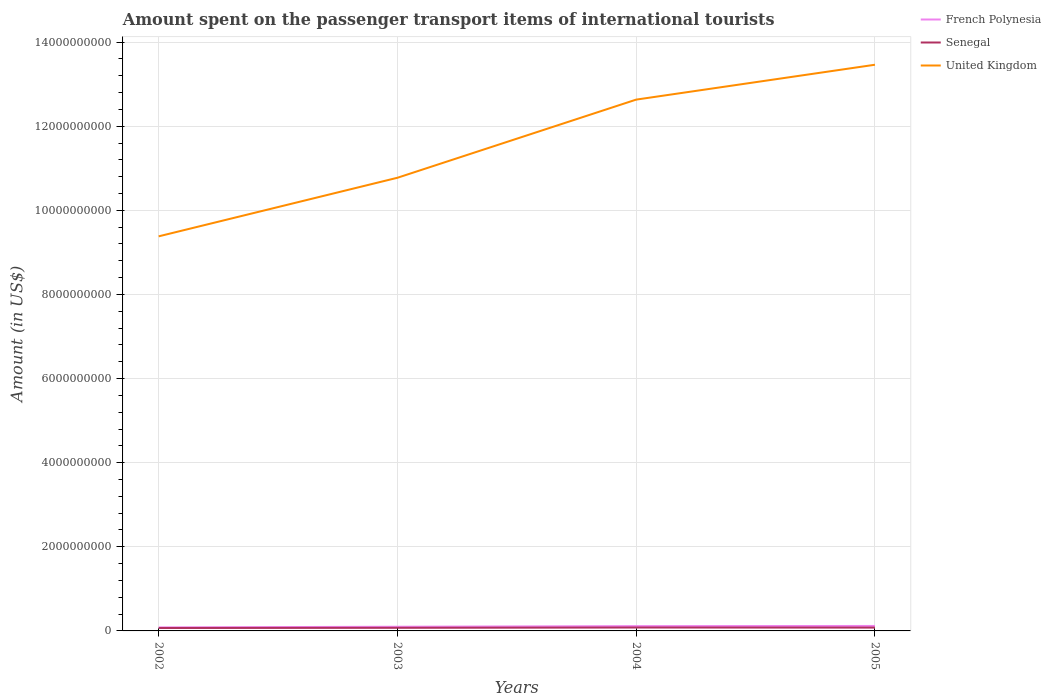Does the line corresponding to United Kingdom intersect with the line corresponding to French Polynesia?
Provide a short and direct response. No. Across all years, what is the maximum amount spent on the passenger transport items of international tourists in French Polynesia?
Offer a terse response. 8.40e+07. What is the total amount spent on the passenger transport items of international tourists in United Kingdom in the graph?
Provide a short and direct response. -2.69e+09. What is the difference between the highest and the second highest amount spent on the passenger transport items of international tourists in Senegal?
Provide a succinct answer. 1.20e+07. How many lines are there?
Ensure brevity in your answer.  3. How many years are there in the graph?
Offer a very short reply. 4. Are the values on the major ticks of Y-axis written in scientific E-notation?
Give a very brief answer. No. Does the graph contain grids?
Make the answer very short. Yes. How many legend labels are there?
Offer a very short reply. 3. How are the legend labels stacked?
Keep it short and to the point. Vertical. What is the title of the graph?
Your answer should be very brief. Amount spent on the passenger transport items of international tourists. Does "Nepal" appear as one of the legend labels in the graph?
Ensure brevity in your answer.  No. What is the Amount (in US$) of French Polynesia in 2002?
Ensure brevity in your answer.  8.40e+07. What is the Amount (in US$) in Senegal in 2002?
Your response must be concise. 6.90e+07. What is the Amount (in US$) in United Kingdom in 2002?
Keep it short and to the point. 9.38e+09. What is the Amount (in US$) of French Polynesia in 2003?
Make the answer very short. 9.90e+07. What is the Amount (in US$) in Senegal in 2003?
Offer a terse response. 7.40e+07. What is the Amount (in US$) of United Kingdom in 2003?
Provide a short and direct response. 1.08e+1. What is the Amount (in US$) in French Polynesia in 2004?
Give a very brief answer. 1.14e+08. What is the Amount (in US$) in Senegal in 2004?
Your answer should be compact. 8.10e+07. What is the Amount (in US$) of United Kingdom in 2004?
Provide a short and direct response. 1.26e+1. What is the Amount (in US$) of French Polynesia in 2005?
Provide a short and direct response. 1.18e+08. What is the Amount (in US$) of Senegal in 2005?
Ensure brevity in your answer.  7.90e+07. What is the Amount (in US$) in United Kingdom in 2005?
Offer a terse response. 1.35e+1. Across all years, what is the maximum Amount (in US$) of French Polynesia?
Offer a terse response. 1.18e+08. Across all years, what is the maximum Amount (in US$) in Senegal?
Keep it short and to the point. 8.10e+07. Across all years, what is the maximum Amount (in US$) of United Kingdom?
Make the answer very short. 1.35e+1. Across all years, what is the minimum Amount (in US$) of French Polynesia?
Keep it short and to the point. 8.40e+07. Across all years, what is the minimum Amount (in US$) of Senegal?
Offer a very short reply. 6.90e+07. Across all years, what is the minimum Amount (in US$) of United Kingdom?
Give a very brief answer. 9.38e+09. What is the total Amount (in US$) of French Polynesia in the graph?
Provide a succinct answer. 4.15e+08. What is the total Amount (in US$) of Senegal in the graph?
Provide a succinct answer. 3.03e+08. What is the total Amount (in US$) of United Kingdom in the graph?
Ensure brevity in your answer.  4.62e+1. What is the difference between the Amount (in US$) in French Polynesia in 2002 and that in 2003?
Ensure brevity in your answer.  -1.50e+07. What is the difference between the Amount (in US$) of Senegal in 2002 and that in 2003?
Ensure brevity in your answer.  -5.00e+06. What is the difference between the Amount (in US$) of United Kingdom in 2002 and that in 2003?
Ensure brevity in your answer.  -1.39e+09. What is the difference between the Amount (in US$) of French Polynesia in 2002 and that in 2004?
Ensure brevity in your answer.  -3.00e+07. What is the difference between the Amount (in US$) of Senegal in 2002 and that in 2004?
Make the answer very short. -1.20e+07. What is the difference between the Amount (in US$) of United Kingdom in 2002 and that in 2004?
Keep it short and to the point. -3.25e+09. What is the difference between the Amount (in US$) in French Polynesia in 2002 and that in 2005?
Offer a very short reply. -3.40e+07. What is the difference between the Amount (in US$) of Senegal in 2002 and that in 2005?
Make the answer very short. -1.00e+07. What is the difference between the Amount (in US$) of United Kingdom in 2002 and that in 2005?
Ensure brevity in your answer.  -4.08e+09. What is the difference between the Amount (in US$) in French Polynesia in 2003 and that in 2004?
Your answer should be compact. -1.50e+07. What is the difference between the Amount (in US$) in Senegal in 2003 and that in 2004?
Keep it short and to the point. -7.00e+06. What is the difference between the Amount (in US$) in United Kingdom in 2003 and that in 2004?
Provide a succinct answer. -1.86e+09. What is the difference between the Amount (in US$) of French Polynesia in 2003 and that in 2005?
Make the answer very short. -1.90e+07. What is the difference between the Amount (in US$) in Senegal in 2003 and that in 2005?
Your answer should be very brief. -5.00e+06. What is the difference between the Amount (in US$) of United Kingdom in 2003 and that in 2005?
Ensure brevity in your answer.  -2.69e+09. What is the difference between the Amount (in US$) in United Kingdom in 2004 and that in 2005?
Your answer should be very brief. -8.29e+08. What is the difference between the Amount (in US$) in French Polynesia in 2002 and the Amount (in US$) in United Kingdom in 2003?
Make the answer very short. -1.07e+1. What is the difference between the Amount (in US$) of Senegal in 2002 and the Amount (in US$) of United Kingdom in 2003?
Make the answer very short. -1.07e+1. What is the difference between the Amount (in US$) in French Polynesia in 2002 and the Amount (in US$) in United Kingdom in 2004?
Your answer should be compact. -1.25e+1. What is the difference between the Amount (in US$) of Senegal in 2002 and the Amount (in US$) of United Kingdom in 2004?
Provide a succinct answer. -1.26e+1. What is the difference between the Amount (in US$) in French Polynesia in 2002 and the Amount (in US$) in Senegal in 2005?
Provide a short and direct response. 5.00e+06. What is the difference between the Amount (in US$) in French Polynesia in 2002 and the Amount (in US$) in United Kingdom in 2005?
Your response must be concise. -1.34e+1. What is the difference between the Amount (in US$) of Senegal in 2002 and the Amount (in US$) of United Kingdom in 2005?
Your answer should be very brief. -1.34e+1. What is the difference between the Amount (in US$) of French Polynesia in 2003 and the Amount (in US$) of Senegal in 2004?
Provide a succinct answer. 1.80e+07. What is the difference between the Amount (in US$) in French Polynesia in 2003 and the Amount (in US$) in United Kingdom in 2004?
Offer a terse response. -1.25e+1. What is the difference between the Amount (in US$) in Senegal in 2003 and the Amount (in US$) in United Kingdom in 2004?
Provide a short and direct response. -1.26e+1. What is the difference between the Amount (in US$) in French Polynesia in 2003 and the Amount (in US$) in United Kingdom in 2005?
Your response must be concise. -1.34e+1. What is the difference between the Amount (in US$) in Senegal in 2003 and the Amount (in US$) in United Kingdom in 2005?
Your response must be concise. -1.34e+1. What is the difference between the Amount (in US$) in French Polynesia in 2004 and the Amount (in US$) in Senegal in 2005?
Your response must be concise. 3.50e+07. What is the difference between the Amount (in US$) of French Polynesia in 2004 and the Amount (in US$) of United Kingdom in 2005?
Your response must be concise. -1.33e+1. What is the difference between the Amount (in US$) of Senegal in 2004 and the Amount (in US$) of United Kingdom in 2005?
Make the answer very short. -1.34e+1. What is the average Amount (in US$) in French Polynesia per year?
Provide a succinct answer. 1.04e+08. What is the average Amount (in US$) in Senegal per year?
Provide a succinct answer. 7.58e+07. What is the average Amount (in US$) in United Kingdom per year?
Your response must be concise. 1.16e+1. In the year 2002, what is the difference between the Amount (in US$) of French Polynesia and Amount (in US$) of Senegal?
Ensure brevity in your answer.  1.50e+07. In the year 2002, what is the difference between the Amount (in US$) in French Polynesia and Amount (in US$) in United Kingdom?
Your answer should be compact. -9.30e+09. In the year 2002, what is the difference between the Amount (in US$) of Senegal and Amount (in US$) of United Kingdom?
Make the answer very short. -9.31e+09. In the year 2003, what is the difference between the Amount (in US$) of French Polynesia and Amount (in US$) of Senegal?
Provide a succinct answer. 2.50e+07. In the year 2003, what is the difference between the Amount (in US$) in French Polynesia and Amount (in US$) in United Kingdom?
Provide a succinct answer. -1.07e+1. In the year 2003, what is the difference between the Amount (in US$) in Senegal and Amount (in US$) in United Kingdom?
Your answer should be compact. -1.07e+1. In the year 2004, what is the difference between the Amount (in US$) of French Polynesia and Amount (in US$) of Senegal?
Make the answer very short. 3.30e+07. In the year 2004, what is the difference between the Amount (in US$) of French Polynesia and Amount (in US$) of United Kingdom?
Provide a short and direct response. -1.25e+1. In the year 2004, what is the difference between the Amount (in US$) in Senegal and Amount (in US$) in United Kingdom?
Make the answer very short. -1.26e+1. In the year 2005, what is the difference between the Amount (in US$) in French Polynesia and Amount (in US$) in Senegal?
Keep it short and to the point. 3.90e+07. In the year 2005, what is the difference between the Amount (in US$) of French Polynesia and Amount (in US$) of United Kingdom?
Your response must be concise. -1.33e+1. In the year 2005, what is the difference between the Amount (in US$) in Senegal and Amount (in US$) in United Kingdom?
Make the answer very short. -1.34e+1. What is the ratio of the Amount (in US$) of French Polynesia in 2002 to that in 2003?
Offer a very short reply. 0.85. What is the ratio of the Amount (in US$) in Senegal in 2002 to that in 2003?
Give a very brief answer. 0.93. What is the ratio of the Amount (in US$) of United Kingdom in 2002 to that in 2003?
Provide a succinct answer. 0.87. What is the ratio of the Amount (in US$) in French Polynesia in 2002 to that in 2004?
Ensure brevity in your answer.  0.74. What is the ratio of the Amount (in US$) of Senegal in 2002 to that in 2004?
Offer a terse response. 0.85. What is the ratio of the Amount (in US$) in United Kingdom in 2002 to that in 2004?
Give a very brief answer. 0.74. What is the ratio of the Amount (in US$) of French Polynesia in 2002 to that in 2005?
Provide a succinct answer. 0.71. What is the ratio of the Amount (in US$) of Senegal in 2002 to that in 2005?
Offer a very short reply. 0.87. What is the ratio of the Amount (in US$) in United Kingdom in 2002 to that in 2005?
Your answer should be compact. 0.7. What is the ratio of the Amount (in US$) of French Polynesia in 2003 to that in 2004?
Offer a terse response. 0.87. What is the ratio of the Amount (in US$) in Senegal in 2003 to that in 2004?
Provide a succinct answer. 0.91. What is the ratio of the Amount (in US$) of United Kingdom in 2003 to that in 2004?
Provide a short and direct response. 0.85. What is the ratio of the Amount (in US$) of French Polynesia in 2003 to that in 2005?
Provide a short and direct response. 0.84. What is the ratio of the Amount (in US$) of Senegal in 2003 to that in 2005?
Your answer should be compact. 0.94. What is the ratio of the Amount (in US$) of United Kingdom in 2003 to that in 2005?
Offer a very short reply. 0.8. What is the ratio of the Amount (in US$) of French Polynesia in 2004 to that in 2005?
Offer a very short reply. 0.97. What is the ratio of the Amount (in US$) of Senegal in 2004 to that in 2005?
Provide a short and direct response. 1.03. What is the ratio of the Amount (in US$) of United Kingdom in 2004 to that in 2005?
Your answer should be very brief. 0.94. What is the difference between the highest and the second highest Amount (in US$) in United Kingdom?
Make the answer very short. 8.29e+08. What is the difference between the highest and the lowest Amount (in US$) in French Polynesia?
Offer a very short reply. 3.40e+07. What is the difference between the highest and the lowest Amount (in US$) in Senegal?
Your answer should be compact. 1.20e+07. What is the difference between the highest and the lowest Amount (in US$) in United Kingdom?
Ensure brevity in your answer.  4.08e+09. 